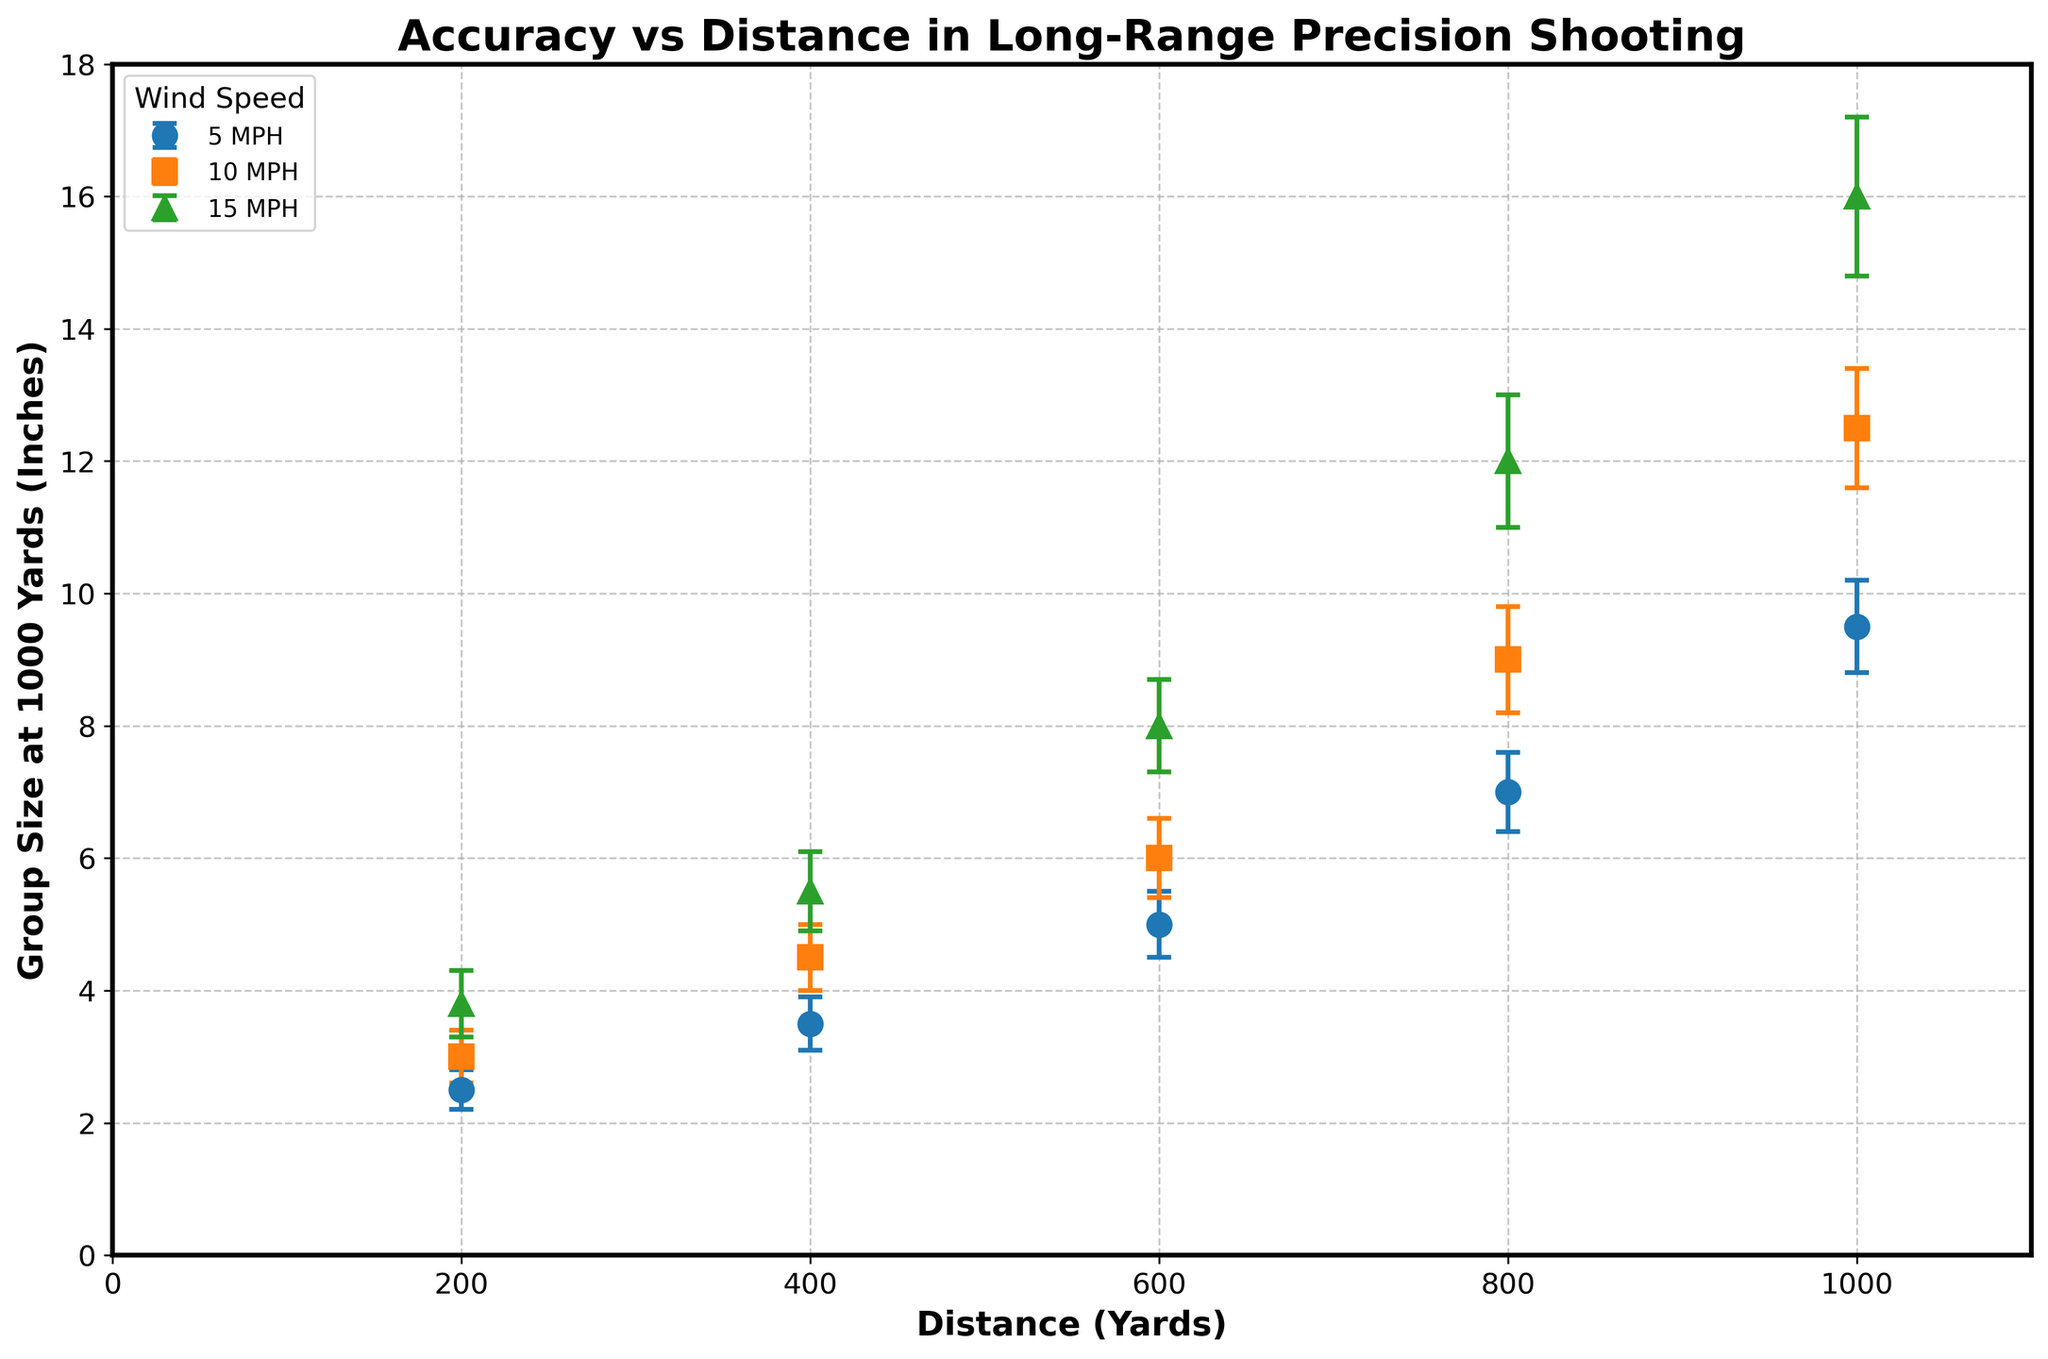What's the title of the figure? The title of a figure is typically located at the top. It serves as a brief description of what the figure represents.
Answer: Accuracy vs Distance in Long-Range Precision Shooting What does the y-axis represent in the figure? The y-axis usually represents the dependent variable in a plot and is labeled to provide context to the data points. In this plot, the y-axis is labeled, indicating it represents "Group Size at 1000 Yards (Inches)".
Answer: Group Size at 1000 Yards (Inches) How many wind speeds are represented in the figure? By examining the legend of the plot, we can identify the different wind speeds represented. There are markers with distinct colors and shapes for each wind speed.
Answer: 3 What is the group size at 1000 yards for a distance of 600 yards with a wind speed of 10 MPH? To find the group size for a specific distance and wind speed, locate the point where the distance is 600 yards and the wind speed is 10 MPH, then read the corresponding y-value.
Answer: 6.0 inches Which wind speed has the largest group size at the maximum distance shown? Identify the data points at the maximum distance (1000 yards) and compare their group sizes. The point with the highest y-value represents the largest group size.
Answer: 15 MPH As distance increases, how does the group size at 1000 yards change for the 5 MPH wind speed? Follow the trend of the data points associated with the 5 MPH wind speed. We observe the trend by checking how the y-values change as the x-values increase.
Answer: Group size increases What is the difference in group size between a wind speed of 5 MPH and 15 MPH at 800 yards? Locate the group sizes for both wind speeds at 800 yards and subtract the smaller value from the larger value.
Answer: 5.0 inches Which wind speed shows the greatest variation in group size across all distances? To identify the wind speed with the greatest variation, compare the range of group sizes for each wind speed. Check the difference between the smallest and largest group sizes for each wind speed.
Answer: 15 MPH What is the average group size at 1000 yards for all wind speeds? Sum up the group sizes at 1000 yards for all wind speeds, then divide by the number of data points. For wind speeds of 5, 10, and 15 MPH, the group sizes are 9.5, 12.5, and 16.0 inches, respectively. (9.5 + 12.5 + 16.0) / 3
Answer: 12.7 inches How does error change with increasing wind speed for a distance of 400 yards? Review the error bars for the data points where the distance is 400 yards, comparing the sizes of the error bars for wind speeds of 5, 10, and 15 MPH.
Answer: Error increases with higher wind speed 